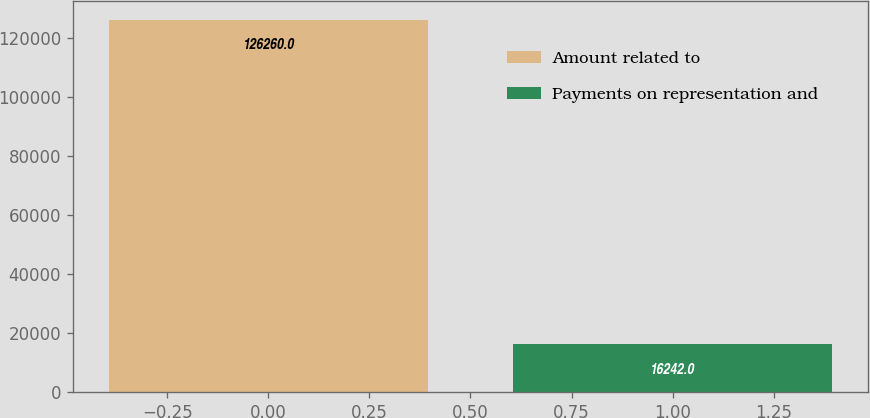Convert chart to OTSL. <chart><loc_0><loc_0><loc_500><loc_500><bar_chart><fcel>Amount related to<fcel>Payments on representation and<nl><fcel>126260<fcel>16242<nl></chart> 